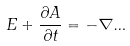<formula> <loc_0><loc_0><loc_500><loc_500>E + \frac { \partial A } { \partial t } = - \nabla \Phi</formula> 